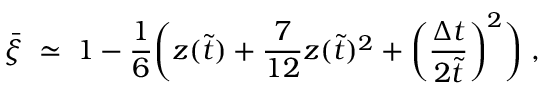Convert formula to latex. <formula><loc_0><loc_0><loc_500><loc_500>\bar { \xi } \, \simeq \, 1 - \frac { 1 } { 6 } \left ( z ( \tilde { t } ) + \frac { 7 } { 1 2 } z ( \tilde { t } ) ^ { 2 } + \left ( \frac { \Delta t } { 2 \tilde { t } } \right ) ^ { 2 } \right ) \, ,</formula> 